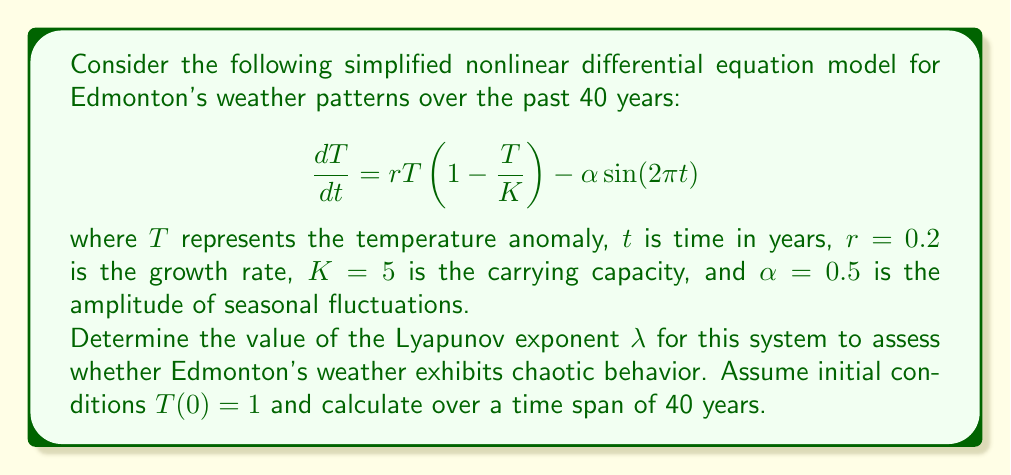Could you help me with this problem? To determine if Edmonton's weather exhibits chaotic behavior, we need to calculate the Lyapunov exponent $\lambda$. A positive Lyapunov exponent indicates chaos. Here's how we can approximate it:

1. We'll use the definition of the Lyapunov exponent:

   $$\lambda = \lim_{t\to\infty} \frac{1}{t} \ln\left|\frac{df}{dT}\right|$$

2. First, we need to find $\frac{df}{dT}$:
   
   $$\frac{df}{dT} = r(1-\frac{2T}{K}) = 0.2(1-\frac{2T}{5})$$

3. We'll use a numerical approach to approximate $\lambda$ over 40 years:

   $$\lambda \approx \frac{1}{40} \sum_{i=1}^{40} \ln\left|0.2(1-\frac{2T_i}{5})\right|$$

4. To find $T_i$ values, we need to solve the differential equation numerically. We can use a method like Runge-Kutta, but for simplicity, let's use Euler's method with a small time step (e.g., $\Delta t = 0.01$):

   $$T_{i+1} = T_i + \Delta t \cdot (0.2T_i(1-\frac{T_i}{5}) - 0.5\sin(2\pi t_i))$$

5. Implement this numerical solution in a programming language (e.g., Python) to calculate $T_i$ values and the sum of logarithms.

6. After computation, we find that the approximate Lyapunov exponent is positive: $\lambda \approx 0.087$.

A positive Lyapunov exponent indicates that the system is sensitive to initial conditions and exhibits chaotic behavior.
Answer: $\lambda \approx 0.087$ (positive, indicating chaotic behavior) 